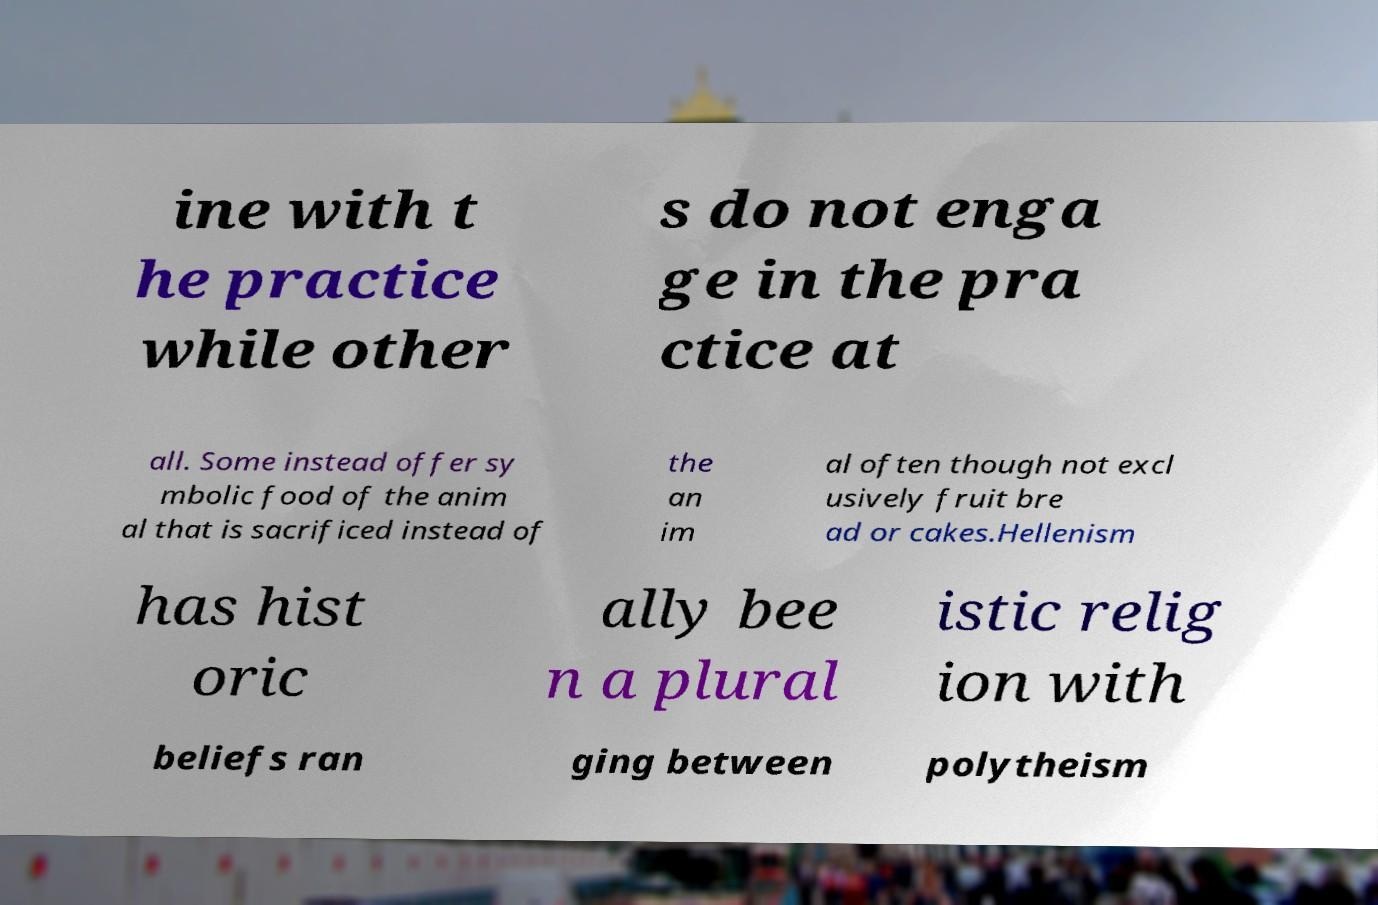Please read and relay the text visible in this image. What does it say? ine with t he practice while other s do not enga ge in the pra ctice at all. Some instead offer sy mbolic food of the anim al that is sacrificed instead of the an im al often though not excl usively fruit bre ad or cakes.Hellenism has hist oric ally bee n a plural istic relig ion with beliefs ran ging between polytheism 